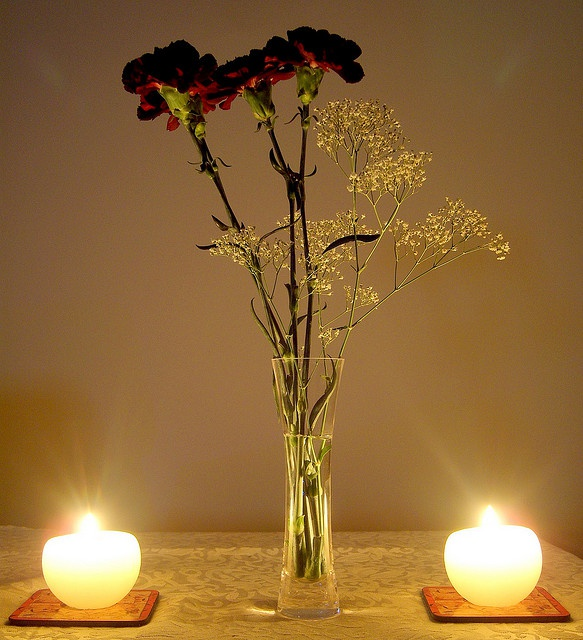Describe the objects in this image and their specific colors. I can see a vase in black, olive, and gray tones in this image. 